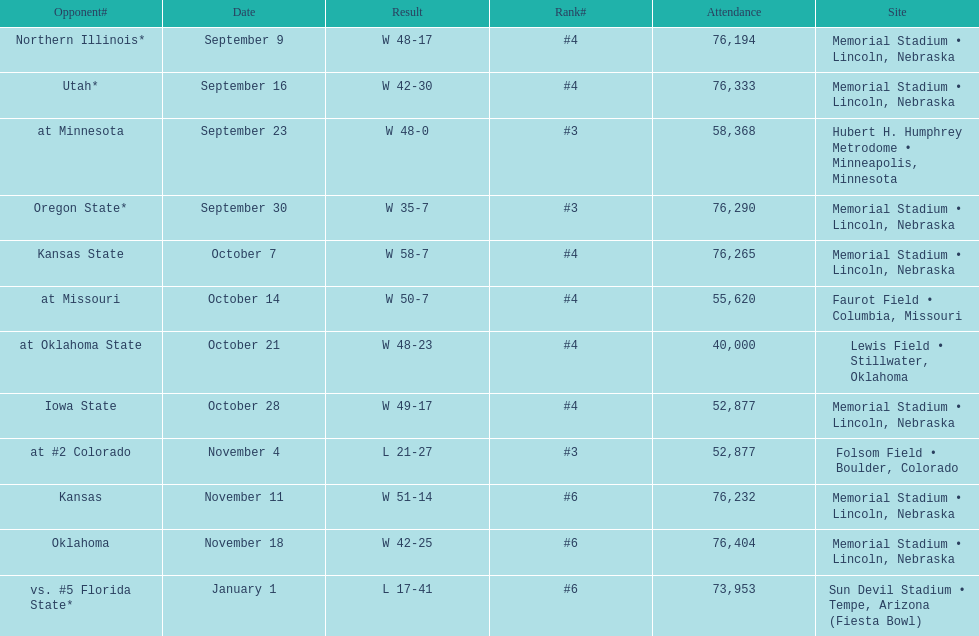Which opponenets did the nebraska cornhuskers score fewer than 40 points against? Oregon State*, at #2 Colorado, vs. #5 Florida State*. Of these games, which ones had an attendance of greater than 70,000? Oregon State*, vs. #5 Florida State*. Which of these opponents did they beat? Oregon State*. How many people were in attendance at that game? 76,290. 